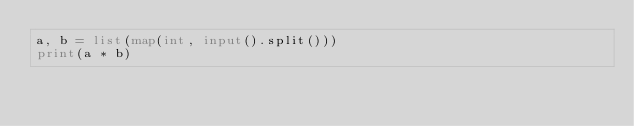<code> <loc_0><loc_0><loc_500><loc_500><_Python_>a, b = list(map(int, input().split()))
print(a * b)
</code> 